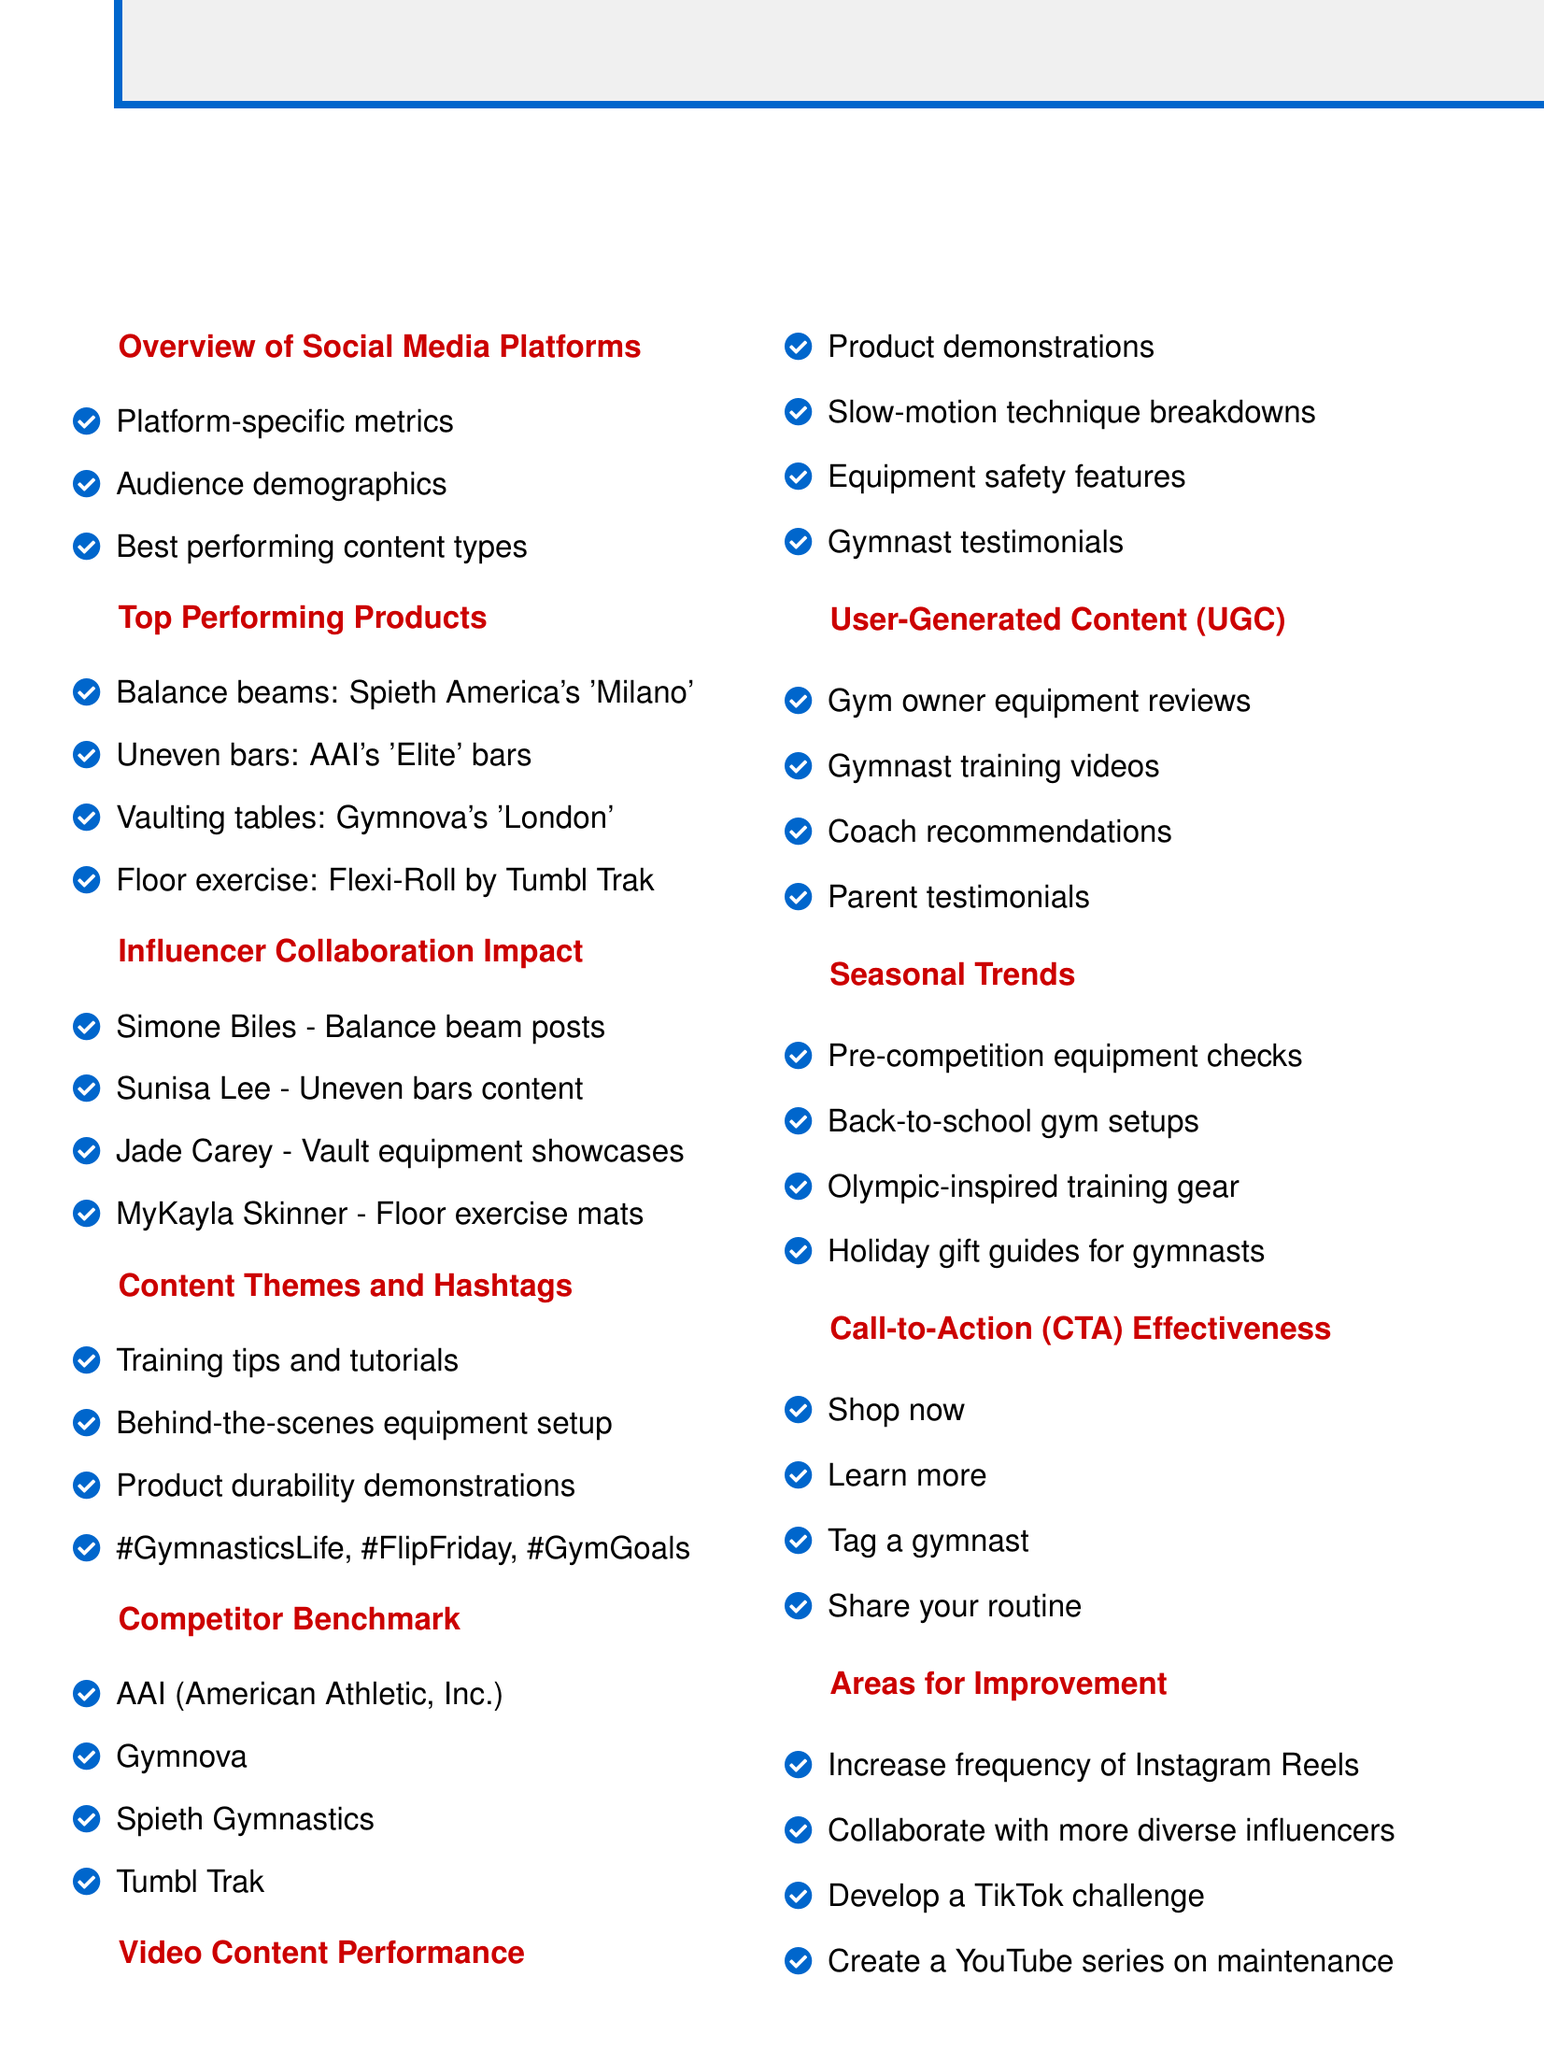What are the social media platforms analyzed? The social media platforms analyzed include Instagram, Facebook, TikTok, and YouTube.
Answer: Instagram, Facebook, TikTok, YouTube Which gymnastics equipment product had the highest engagement? The top performing product in engagement was the balance beam by Spieth America, named 'Milano'.
Answer: 'Milano' beam Who is the gymnast with the most followers mentioned in the influencer collaboration section? Simone Biles has the most followers at 4.3 million.
Answer: 4.3M followers What content type was evaluated for performance in videos? The analysis included product demonstrations and slow-motion technique breakdowns among others.
Answer: Product demonstrations What is the hashtag mentioned associated with training? One of the hashtags mentioned is '#GymnasticsLife'.
Answer: #GymnasticsLife Which competitor brands are listed for benchmarking? The competitor brands listed are AAI, Gymnova, Spieth Gymnastics, and Tumbl Trak.
Answer: AAI, Gymnova, Spieth Gymnastics, Tumbl Trak What is the proposed strategy for improvement regarding TikTok? The agenda suggests developing a TikTok challenge for equipment showcase as a strategy for improvement.
Answer: TikTok challenge What area of content was highlighted for user-generated contributions? The impact of user-generated content (UGC) was highlighted, including gym owner equipment reviews.
Answer: Equipment reviews What is one of the seasonal trends identified? One of the seasonal trends identified is pre-competition equipment checks.
Answer: Pre-competition equipment checks 